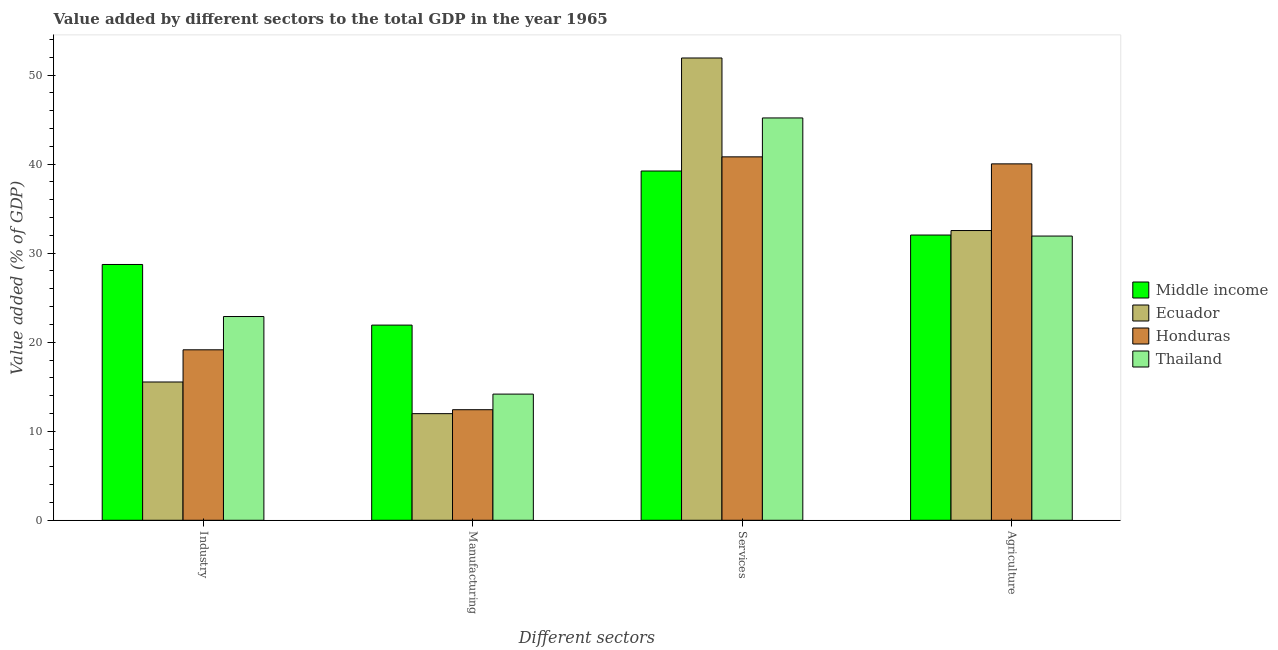How many groups of bars are there?
Keep it short and to the point. 4. Are the number of bars on each tick of the X-axis equal?
Offer a terse response. Yes. How many bars are there on the 2nd tick from the left?
Your response must be concise. 4. How many bars are there on the 2nd tick from the right?
Keep it short and to the point. 4. What is the label of the 3rd group of bars from the left?
Your answer should be compact. Services. What is the value added by services sector in Middle income?
Offer a very short reply. 39.23. Across all countries, what is the maximum value added by industrial sector?
Offer a terse response. 28.73. Across all countries, what is the minimum value added by agricultural sector?
Your answer should be very brief. 31.92. In which country was the value added by agricultural sector maximum?
Offer a terse response. Honduras. In which country was the value added by industrial sector minimum?
Make the answer very short. Ecuador. What is the total value added by manufacturing sector in the graph?
Your answer should be very brief. 60.49. What is the difference between the value added by agricultural sector in Ecuador and that in Honduras?
Your answer should be compact. -7.49. What is the difference between the value added by industrial sector in Middle income and the value added by manufacturing sector in Ecuador?
Your answer should be compact. 16.75. What is the average value added by manufacturing sector per country?
Provide a succinct answer. 15.12. What is the difference between the value added by manufacturing sector and value added by services sector in Thailand?
Your answer should be compact. -31.02. In how many countries, is the value added by services sector greater than 50 %?
Your response must be concise. 1. What is the ratio of the value added by agricultural sector in Thailand to that in Ecuador?
Your answer should be compact. 0.98. Is the value added by industrial sector in Thailand less than that in Middle income?
Give a very brief answer. Yes. What is the difference between the highest and the second highest value added by manufacturing sector?
Make the answer very short. 7.75. What is the difference between the highest and the lowest value added by manufacturing sector?
Offer a very short reply. 9.95. In how many countries, is the value added by industrial sector greater than the average value added by industrial sector taken over all countries?
Provide a succinct answer. 2. Is the sum of the value added by manufacturing sector in Thailand and Honduras greater than the maximum value added by services sector across all countries?
Keep it short and to the point. No. What does the 3rd bar from the left in Agriculture represents?
Your answer should be compact. Honduras. What does the 1st bar from the right in Manufacturing represents?
Your answer should be compact. Thailand. Are all the bars in the graph horizontal?
Provide a succinct answer. No. How many countries are there in the graph?
Offer a very short reply. 4. What is the difference between two consecutive major ticks on the Y-axis?
Provide a succinct answer. 10. Does the graph contain grids?
Provide a short and direct response. No. How are the legend labels stacked?
Give a very brief answer. Vertical. What is the title of the graph?
Your answer should be compact. Value added by different sectors to the total GDP in the year 1965. Does "Canada" appear as one of the legend labels in the graph?
Your answer should be very brief. No. What is the label or title of the X-axis?
Make the answer very short. Different sectors. What is the label or title of the Y-axis?
Ensure brevity in your answer.  Value added (% of GDP). What is the Value added (% of GDP) in Middle income in Industry?
Keep it short and to the point. 28.73. What is the Value added (% of GDP) of Ecuador in Industry?
Keep it short and to the point. 15.53. What is the Value added (% of GDP) of Honduras in Industry?
Provide a succinct answer. 19.15. What is the Value added (% of GDP) in Thailand in Industry?
Your response must be concise. 22.89. What is the Value added (% of GDP) of Middle income in Manufacturing?
Give a very brief answer. 21.92. What is the Value added (% of GDP) in Ecuador in Manufacturing?
Offer a terse response. 11.98. What is the Value added (% of GDP) in Honduras in Manufacturing?
Provide a short and direct response. 12.42. What is the Value added (% of GDP) of Thailand in Manufacturing?
Your answer should be very brief. 14.17. What is the Value added (% of GDP) of Middle income in Services?
Provide a short and direct response. 39.23. What is the Value added (% of GDP) in Ecuador in Services?
Make the answer very short. 51.93. What is the Value added (% of GDP) in Honduras in Services?
Your response must be concise. 40.82. What is the Value added (% of GDP) of Thailand in Services?
Offer a very short reply. 45.19. What is the Value added (% of GDP) of Middle income in Agriculture?
Offer a very short reply. 32.04. What is the Value added (% of GDP) in Ecuador in Agriculture?
Keep it short and to the point. 32.54. What is the Value added (% of GDP) of Honduras in Agriculture?
Provide a succinct answer. 40.03. What is the Value added (% of GDP) in Thailand in Agriculture?
Your answer should be very brief. 31.92. Across all Different sectors, what is the maximum Value added (% of GDP) in Middle income?
Your answer should be compact. 39.23. Across all Different sectors, what is the maximum Value added (% of GDP) of Ecuador?
Offer a terse response. 51.93. Across all Different sectors, what is the maximum Value added (% of GDP) of Honduras?
Offer a terse response. 40.82. Across all Different sectors, what is the maximum Value added (% of GDP) in Thailand?
Your response must be concise. 45.19. Across all Different sectors, what is the minimum Value added (% of GDP) in Middle income?
Your answer should be compact. 21.92. Across all Different sectors, what is the minimum Value added (% of GDP) in Ecuador?
Give a very brief answer. 11.98. Across all Different sectors, what is the minimum Value added (% of GDP) in Honduras?
Keep it short and to the point. 12.42. Across all Different sectors, what is the minimum Value added (% of GDP) in Thailand?
Your answer should be compact. 14.17. What is the total Value added (% of GDP) of Middle income in the graph?
Your answer should be compact. 121.92. What is the total Value added (% of GDP) of Ecuador in the graph?
Ensure brevity in your answer.  111.98. What is the total Value added (% of GDP) of Honduras in the graph?
Keep it short and to the point. 112.42. What is the total Value added (% of GDP) of Thailand in the graph?
Ensure brevity in your answer.  114.17. What is the difference between the Value added (% of GDP) in Middle income in Industry and that in Manufacturing?
Your answer should be very brief. 6.81. What is the difference between the Value added (% of GDP) of Ecuador in Industry and that in Manufacturing?
Your answer should be compact. 3.56. What is the difference between the Value added (% of GDP) in Honduras in Industry and that in Manufacturing?
Your response must be concise. 6.73. What is the difference between the Value added (% of GDP) in Thailand in Industry and that in Manufacturing?
Provide a short and direct response. 8.71. What is the difference between the Value added (% of GDP) in Middle income in Industry and that in Services?
Give a very brief answer. -10.5. What is the difference between the Value added (% of GDP) in Ecuador in Industry and that in Services?
Ensure brevity in your answer.  -36.39. What is the difference between the Value added (% of GDP) in Honduras in Industry and that in Services?
Provide a succinct answer. -21.67. What is the difference between the Value added (% of GDP) of Thailand in Industry and that in Services?
Provide a succinct answer. -22.31. What is the difference between the Value added (% of GDP) of Middle income in Industry and that in Agriculture?
Ensure brevity in your answer.  -3.31. What is the difference between the Value added (% of GDP) of Ecuador in Industry and that in Agriculture?
Your answer should be compact. -17.01. What is the difference between the Value added (% of GDP) of Honduras in Industry and that in Agriculture?
Make the answer very short. -20.89. What is the difference between the Value added (% of GDP) of Thailand in Industry and that in Agriculture?
Offer a terse response. -9.04. What is the difference between the Value added (% of GDP) in Middle income in Manufacturing and that in Services?
Offer a terse response. -17.31. What is the difference between the Value added (% of GDP) of Ecuador in Manufacturing and that in Services?
Provide a short and direct response. -39.95. What is the difference between the Value added (% of GDP) in Honduras in Manufacturing and that in Services?
Keep it short and to the point. -28.4. What is the difference between the Value added (% of GDP) in Thailand in Manufacturing and that in Services?
Your answer should be compact. -31.02. What is the difference between the Value added (% of GDP) in Middle income in Manufacturing and that in Agriculture?
Offer a very short reply. -10.12. What is the difference between the Value added (% of GDP) of Ecuador in Manufacturing and that in Agriculture?
Make the answer very short. -20.57. What is the difference between the Value added (% of GDP) of Honduras in Manufacturing and that in Agriculture?
Offer a terse response. -27.61. What is the difference between the Value added (% of GDP) in Thailand in Manufacturing and that in Agriculture?
Offer a very short reply. -17.75. What is the difference between the Value added (% of GDP) of Middle income in Services and that in Agriculture?
Provide a succinct answer. 7.19. What is the difference between the Value added (% of GDP) in Ecuador in Services and that in Agriculture?
Ensure brevity in your answer.  19.38. What is the difference between the Value added (% of GDP) in Honduras in Services and that in Agriculture?
Offer a very short reply. 0.79. What is the difference between the Value added (% of GDP) in Thailand in Services and that in Agriculture?
Make the answer very short. 13.27. What is the difference between the Value added (% of GDP) of Middle income in Industry and the Value added (% of GDP) of Ecuador in Manufacturing?
Provide a succinct answer. 16.75. What is the difference between the Value added (% of GDP) of Middle income in Industry and the Value added (% of GDP) of Honduras in Manufacturing?
Give a very brief answer. 16.31. What is the difference between the Value added (% of GDP) of Middle income in Industry and the Value added (% of GDP) of Thailand in Manufacturing?
Keep it short and to the point. 14.56. What is the difference between the Value added (% of GDP) of Ecuador in Industry and the Value added (% of GDP) of Honduras in Manufacturing?
Make the answer very short. 3.11. What is the difference between the Value added (% of GDP) in Ecuador in Industry and the Value added (% of GDP) in Thailand in Manufacturing?
Ensure brevity in your answer.  1.36. What is the difference between the Value added (% of GDP) in Honduras in Industry and the Value added (% of GDP) in Thailand in Manufacturing?
Your answer should be compact. 4.98. What is the difference between the Value added (% of GDP) of Middle income in Industry and the Value added (% of GDP) of Ecuador in Services?
Offer a very short reply. -23.19. What is the difference between the Value added (% of GDP) in Middle income in Industry and the Value added (% of GDP) in Honduras in Services?
Your answer should be very brief. -12.09. What is the difference between the Value added (% of GDP) in Middle income in Industry and the Value added (% of GDP) in Thailand in Services?
Make the answer very short. -16.46. What is the difference between the Value added (% of GDP) in Ecuador in Industry and the Value added (% of GDP) in Honduras in Services?
Provide a short and direct response. -25.29. What is the difference between the Value added (% of GDP) in Ecuador in Industry and the Value added (% of GDP) in Thailand in Services?
Ensure brevity in your answer.  -29.66. What is the difference between the Value added (% of GDP) in Honduras in Industry and the Value added (% of GDP) in Thailand in Services?
Offer a very short reply. -26.04. What is the difference between the Value added (% of GDP) of Middle income in Industry and the Value added (% of GDP) of Ecuador in Agriculture?
Your response must be concise. -3.81. What is the difference between the Value added (% of GDP) in Middle income in Industry and the Value added (% of GDP) in Honduras in Agriculture?
Offer a terse response. -11.3. What is the difference between the Value added (% of GDP) in Middle income in Industry and the Value added (% of GDP) in Thailand in Agriculture?
Offer a very short reply. -3.19. What is the difference between the Value added (% of GDP) of Ecuador in Industry and the Value added (% of GDP) of Honduras in Agriculture?
Offer a very short reply. -24.5. What is the difference between the Value added (% of GDP) in Ecuador in Industry and the Value added (% of GDP) in Thailand in Agriculture?
Give a very brief answer. -16.39. What is the difference between the Value added (% of GDP) in Honduras in Industry and the Value added (% of GDP) in Thailand in Agriculture?
Make the answer very short. -12.78. What is the difference between the Value added (% of GDP) in Middle income in Manufacturing and the Value added (% of GDP) in Ecuador in Services?
Make the answer very short. -30. What is the difference between the Value added (% of GDP) in Middle income in Manufacturing and the Value added (% of GDP) in Honduras in Services?
Offer a very short reply. -18.9. What is the difference between the Value added (% of GDP) of Middle income in Manufacturing and the Value added (% of GDP) of Thailand in Services?
Provide a short and direct response. -23.27. What is the difference between the Value added (% of GDP) of Ecuador in Manufacturing and the Value added (% of GDP) of Honduras in Services?
Provide a succinct answer. -28.84. What is the difference between the Value added (% of GDP) in Ecuador in Manufacturing and the Value added (% of GDP) in Thailand in Services?
Offer a very short reply. -33.22. What is the difference between the Value added (% of GDP) of Honduras in Manufacturing and the Value added (% of GDP) of Thailand in Services?
Provide a short and direct response. -32.77. What is the difference between the Value added (% of GDP) in Middle income in Manufacturing and the Value added (% of GDP) in Ecuador in Agriculture?
Provide a succinct answer. -10.62. What is the difference between the Value added (% of GDP) of Middle income in Manufacturing and the Value added (% of GDP) of Honduras in Agriculture?
Ensure brevity in your answer.  -18.11. What is the difference between the Value added (% of GDP) of Middle income in Manufacturing and the Value added (% of GDP) of Thailand in Agriculture?
Offer a very short reply. -10. What is the difference between the Value added (% of GDP) in Ecuador in Manufacturing and the Value added (% of GDP) in Honduras in Agriculture?
Offer a very short reply. -28.06. What is the difference between the Value added (% of GDP) of Ecuador in Manufacturing and the Value added (% of GDP) of Thailand in Agriculture?
Make the answer very short. -19.95. What is the difference between the Value added (% of GDP) in Honduras in Manufacturing and the Value added (% of GDP) in Thailand in Agriculture?
Your answer should be very brief. -19.5. What is the difference between the Value added (% of GDP) of Middle income in Services and the Value added (% of GDP) of Ecuador in Agriculture?
Provide a succinct answer. 6.69. What is the difference between the Value added (% of GDP) of Middle income in Services and the Value added (% of GDP) of Honduras in Agriculture?
Make the answer very short. -0.8. What is the difference between the Value added (% of GDP) of Middle income in Services and the Value added (% of GDP) of Thailand in Agriculture?
Make the answer very short. 7.31. What is the difference between the Value added (% of GDP) in Ecuador in Services and the Value added (% of GDP) in Honduras in Agriculture?
Provide a short and direct response. 11.89. What is the difference between the Value added (% of GDP) in Ecuador in Services and the Value added (% of GDP) in Thailand in Agriculture?
Offer a very short reply. 20. What is the difference between the Value added (% of GDP) of Honduras in Services and the Value added (% of GDP) of Thailand in Agriculture?
Offer a terse response. 8.9. What is the average Value added (% of GDP) of Middle income per Different sectors?
Make the answer very short. 30.48. What is the average Value added (% of GDP) of Ecuador per Different sectors?
Your answer should be very brief. 27.99. What is the average Value added (% of GDP) in Honduras per Different sectors?
Offer a very short reply. 28.1. What is the average Value added (% of GDP) of Thailand per Different sectors?
Make the answer very short. 28.54. What is the difference between the Value added (% of GDP) of Middle income and Value added (% of GDP) of Ecuador in Industry?
Your response must be concise. 13.2. What is the difference between the Value added (% of GDP) of Middle income and Value added (% of GDP) of Honduras in Industry?
Ensure brevity in your answer.  9.58. What is the difference between the Value added (% of GDP) in Middle income and Value added (% of GDP) in Thailand in Industry?
Ensure brevity in your answer.  5.85. What is the difference between the Value added (% of GDP) in Ecuador and Value added (% of GDP) in Honduras in Industry?
Offer a terse response. -3.62. What is the difference between the Value added (% of GDP) in Ecuador and Value added (% of GDP) in Thailand in Industry?
Make the answer very short. -7.35. What is the difference between the Value added (% of GDP) in Honduras and Value added (% of GDP) in Thailand in Industry?
Your answer should be very brief. -3.74. What is the difference between the Value added (% of GDP) of Middle income and Value added (% of GDP) of Ecuador in Manufacturing?
Ensure brevity in your answer.  9.95. What is the difference between the Value added (% of GDP) of Middle income and Value added (% of GDP) of Honduras in Manufacturing?
Provide a short and direct response. 9.5. What is the difference between the Value added (% of GDP) in Middle income and Value added (% of GDP) in Thailand in Manufacturing?
Your response must be concise. 7.75. What is the difference between the Value added (% of GDP) of Ecuador and Value added (% of GDP) of Honduras in Manufacturing?
Your answer should be very brief. -0.44. What is the difference between the Value added (% of GDP) of Ecuador and Value added (% of GDP) of Thailand in Manufacturing?
Offer a very short reply. -2.2. What is the difference between the Value added (% of GDP) of Honduras and Value added (% of GDP) of Thailand in Manufacturing?
Your answer should be very brief. -1.75. What is the difference between the Value added (% of GDP) of Middle income and Value added (% of GDP) of Ecuador in Services?
Keep it short and to the point. -12.69. What is the difference between the Value added (% of GDP) in Middle income and Value added (% of GDP) in Honduras in Services?
Your answer should be very brief. -1.59. What is the difference between the Value added (% of GDP) of Middle income and Value added (% of GDP) of Thailand in Services?
Offer a terse response. -5.96. What is the difference between the Value added (% of GDP) in Ecuador and Value added (% of GDP) in Honduras in Services?
Ensure brevity in your answer.  11.1. What is the difference between the Value added (% of GDP) in Ecuador and Value added (% of GDP) in Thailand in Services?
Provide a succinct answer. 6.73. What is the difference between the Value added (% of GDP) of Honduras and Value added (% of GDP) of Thailand in Services?
Offer a very short reply. -4.37. What is the difference between the Value added (% of GDP) of Middle income and Value added (% of GDP) of Ecuador in Agriculture?
Your answer should be very brief. -0.51. What is the difference between the Value added (% of GDP) of Middle income and Value added (% of GDP) of Honduras in Agriculture?
Offer a very short reply. -7.99. What is the difference between the Value added (% of GDP) of Middle income and Value added (% of GDP) of Thailand in Agriculture?
Your answer should be very brief. 0.11. What is the difference between the Value added (% of GDP) of Ecuador and Value added (% of GDP) of Honduras in Agriculture?
Make the answer very short. -7.49. What is the difference between the Value added (% of GDP) in Ecuador and Value added (% of GDP) in Thailand in Agriculture?
Provide a short and direct response. 0.62. What is the difference between the Value added (% of GDP) in Honduras and Value added (% of GDP) in Thailand in Agriculture?
Your response must be concise. 8.11. What is the ratio of the Value added (% of GDP) in Middle income in Industry to that in Manufacturing?
Your response must be concise. 1.31. What is the ratio of the Value added (% of GDP) in Ecuador in Industry to that in Manufacturing?
Provide a short and direct response. 1.3. What is the ratio of the Value added (% of GDP) in Honduras in Industry to that in Manufacturing?
Your answer should be very brief. 1.54. What is the ratio of the Value added (% of GDP) of Thailand in Industry to that in Manufacturing?
Your answer should be very brief. 1.61. What is the ratio of the Value added (% of GDP) of Middle income in Industry to that in Services?
Ensure brevity in your answer.  0.73. What is the ratio of the Value added (% of GDP) of Ecuador in Industry to that in Services?
Make the answer very short. 0.3. What is the ratio of the Value added (% of GDP) in Honduras in Industry to that in Services?
Offer a terse response. 0.47. What is the ratio of the Value added (% of GDP) of Thailand in Industry to that in Services?
Your answer should be very brief. 0.51. What is the ratio of the Value added (% of GDP) of Middle income in Industry to that in Agriculture?
Your answer should be very brief. 0.9. What is the ratio of the Value added (% of GDP) of Ecuador in Industry to that in Agriculture?
Your answer should be compact. 0.48. What is the ratio of the Value added (% of GDP) in Honduras in Industry to that in Agriculture?
Provide a short and direct response. 0.48. What is the ratio of the Value added (% of GDP) of Thailand in Industry to that in Agriculture?
Your answer should be compact. 0.72. What is the ratio of the Value added (% of GDP) of Middle income in Manufacturing to that in Services?
Give a very brief answer. 0.56. What is the ratio of the Value added (% of GDP) in Ecuador in Manufacturing to that in Services?
Provide a short and direct response. 0.23. What is the ratio of the Value added (% of GDP) in Honduras in Manufacturing to that in Services?
Ensure brevity in your answer.  0.3. What is the ratio of the Value added (% of GDP) in Thailand in Manufacturing to that in Services?
Ensure brevity in your answer.  0.31. What is the ratio of the Value added (% of GDP) of Middle income in Manufacturing to that in Agriculture?
Ensure brevity in your answer.  0.68. What is the ratio of the Value added (% of GDP) in Ecuador in Manufacturing to that in Agriculture?
Offer a very short reply. 0.37. What is the ratio of the Value added (% of GDP) in Honduras in Manufacturing to that in Agriculture?
Ensure brevity in your answer.  0.31. What is the ratio of the Value added (% of GDP) of Thailand in Manufacturing to that in Agriculture?
Provide a short and direct response. 0.44. What is the ratio of the Value added (% of GDP) of Middle income in Services to that in Agriculture?
Ensure brevity in your answer.  1.22. What is the ratio of the Value added (% of GDP) of Ecuador in Services to that in Agriculture?
Give a very brief answer. 1.6. What is the ratio of the Value added (% of GDP) of Honduras in Services to that in Agriculture?
Keep it short and to the point. 1.02. What is the ratio of the Value added (% of GDP) of Thailand in Services to that in Agriculture?
Your answer should be compact. 1.42. What is the difference between the highest and the second highest Value added (% of GDP) of Middle income?
Provide a succinct answer. 7.19. What is the difference between the highest and the second highest Value added (% of GDP) in Ecuador?
Provide a succinct answer. 19.38. What is the difference between the highest and the second highest Value added (% of GDP) in Honduras?
Your response must be concise. 0.79. What is the difference between the highest and the second highest Value added (% of GDP) in Thailand?
Your answer should be very brief. 13.27. What is the difference between the highest and the lowest Value added (% of GDP) of Middle income?
Your response must be concise. 17.31. What is the difference between the highest and the lowest Value added (% of GDP) of Ecuador?
Offer a terse response. 39.95. What is the difference between the highest and the lowest Value added (% of GDP) of Honduras?
Your answer should be compact. 28.4. What is the difference between the highest and the lowest Value added (% of GDP) in Thailand?
Make the answer very short. 31.02. 